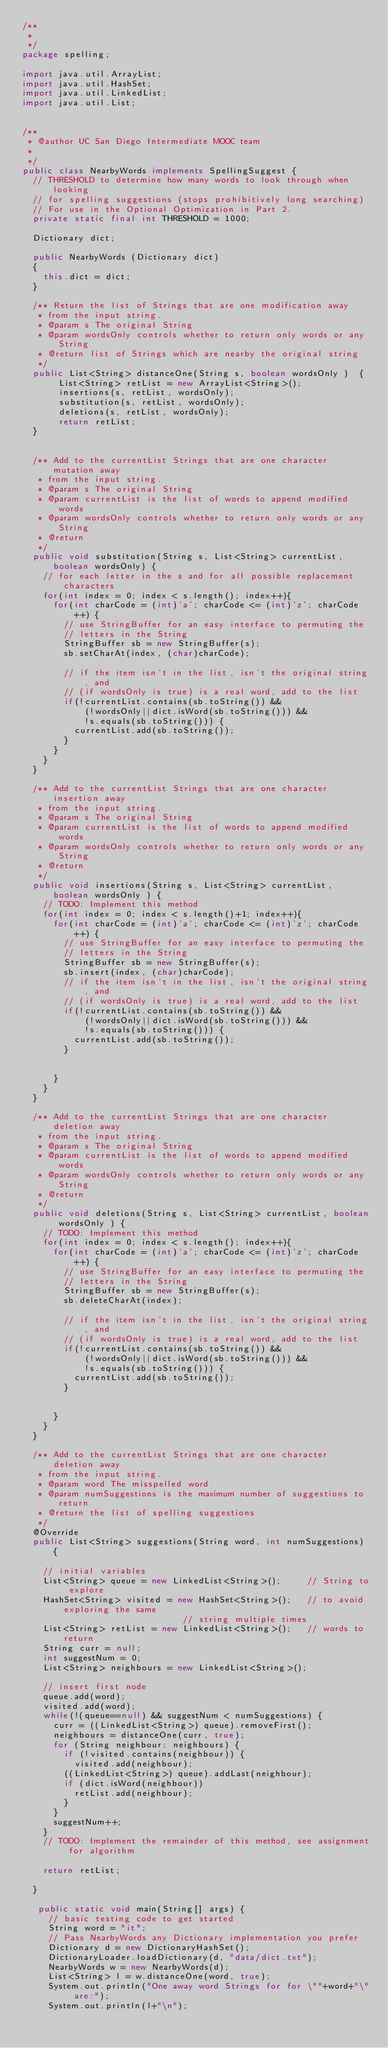<code> <loc_0><loc_0><loc_500><loc_500><_Java_>/**
 * 
 */
package spelling;

import java.util.ArrayList;
import java.util.HashSet;
import java.util.LinkedList;
import java.util.List;


/**
 * @author UC San Diego Intermediate MOOC team
 *
 */
public class NearbyWords implements SpellingSuggest {
	// THRESHOLD to determine how many words to look through when looking
	// for spelling suggestions (stops prohibitively long searching)
	// For use in the Optional Optimization in Part 2.
	private static final int THRESHOLD = 1000; 

	Dictionary dict;

	public NearbyWords (Dictionary dict) 
	{
		this.dict = dict;
	}

	/** Return the list of Strings that are one modification away
	 * from the input string.  
	 * @param s The original String
	 * @param wordsOnly controls whether to return only words or any String
	 * @return list of Strings which are nearby the original string
	 */
	public List<String> distanceOne(String s, boolean wordsOnly )  {
		   List<String> retList = new ArrayList<String>();
		   insertions(s, retList, wordsOnly);
		   substitution(s, retList, wordsOnly);
		   deletions(s, retList, wordsOnly);
		   return retList;
	}

	
	/** Add to the currentList Strings that are one character mutation away
	 * from the input string.  
	 * @param s The original String
	 * @param currentList is the list of words to append modified words 
	 * @param wordsOnly controls whether to return only words or any String
	 * @return
	 */
	public void substitution(String s, List<String> currentList, boolean wordsOnly) {
		// for each letter in the s and for all possible replacement characters
		for(int index = 0; index < s.length(); index++){
			for(int charCode = (int)'a'; charCode <= (int)'z'; charCode++) {
				// use StringBuffer for an easy interface to permuting the 
				// letters in the String
				StringBuffer sb = new StringBuffer(s);
				sb.setCharAt(index, (char)charCode);

				// if the item isn't in the list, isn't the original string, and
				// (if wordsOnly is true) is a real word, add to the list
				if(!currentList.contains(sb.toString()) && 
						(!wordsOnly||dict.isWord(sb.toString())) &&
						!s.equals(sb.toString())) {
					currentList.add(sb.toString());
				}
			}
		}
	}
	
	/** Add to the currentList Strings that are one character insertion away
	 * from the input string.  
	 * @param s The original String
	 * @param currentList is the list of words to append modified words 
	 * @param wordsOnly controls whether to return only words or any String
	 * @return
	 */
	public void insertions(String s, List<String> currentList, boolean wordsOnly ) {
		// TODO: Implement this method
		for(int index = 0; index < s.length()+1; index++){
			for(int charCode = (int)'a'; charCode <= (int)'z'; charCode++) {
				// use StringBuffer for an easy interface to permuting the 
				// letters in the String
				StringBuffer sb = new StringBuffer(s);
				sb.insert(index, (char)charCode);
				// if the item isn't in the list, isn't the original string, and
				// (if wordsOnly is true) is a real word, add to the list
				if(!currentList.contains(sb.toString()) && 
						(!wordsOnly||dict.isWord(sb.toString())) &&
						!s.equals(sb.toString())) {
					currentList.add(sb.toString());
				}
				
				
			}
		}
	}

	/** Add to the currentList Strings that are one character deletion away
	 * from the input string.  
	 * @param s The original String
	 * @param currentList is the list of words to append modified words 
	 * @param wordsOnly controls whether to return only words or any String
	 * @return
	 */
	public void deletions(String s, List<String> currentList, boolean wordsOnly ) {
		// TODO: Implement this method
		for(int index = 0; index < s.length(); index++){
			for(int charCode = (int)'a'; charCode <= (int)'z'; charCode++) {
				// use StringBuffer for an easy interface to permuting the 
				// letters in the String
				StringBuffer sb = new StringBuffer(s);
				sb.deleteCharAt(index);

				// if the item isn't in the list, isn't the original string, and
				// (if wordsOnly is true) is a real word, add to the list
				if(!currentList.contains(sb.toString()) && 
						(!wordsOnly||dict.isWord(sb.toString())) &&
						!s.equals(sb.toString())) {
					currentList.add(sb.toString());
				}
				
				
			}
		}
	}

	/** Add to the currentList Strings that are one character deletion away
	 * from the input string.  
	 * @param word The misspelled word
	 * @param numSuggestions is the maximum number of suggestions to return 
	 * @return the list of spelling suggestions
	 */
	@Override
	public List<String> suggestions(String word, int numSuggestions) {

		// initial variables
		List<String> queue = new LinkedList<String>();     // String to explore
		HashSet<String> visited = new HashSet<String>();   // to avoid exploring the same  
														   // string multiple times
		List<String> retList = new LinkedList<String>();   // words to return
		String curr = null;
		int suggestNum = 0;
		List<String> neighbours = new LinkedList<String>();
		
		// insert first node
		queue.add(word);
		visited.add(word);
		while(!(queue==null) && suggestNum < numSuggestions) {
			curr = ((LinkedList<String>) queue).removeFirst();
			neighbours = distanceOne(curr, true);
			for (String neighbour: neighbours) {
				if (!visited.contains(neighbour)) {
					visited.add(neighbour);
				((LinkedList<String>) queue).addLast(neighbour);
				if (dict.isWord(neighbour))
					retList.add(neighbour);
				}
			}
			suggestNum++;
		}
		// TODO: Implement the remainder of this method, see assignment for algorithm
		
		return retList;

	}	

   public static void main(String[] args) {
	   // basic testing code to get started
	   String word = "it";
	   // Pass NearbyWords any Dictionary implementation you prefer
	   Dictionary d = new DictionaryHashSet();
	   DictionaryLoader.loadDictionary(d, "data/dict.txt");
	   NearbyWords w = new NearbyWords(d);
	   List<String> l = w.distanceOne(word, true);
	   System.out.println("One away word Strings for for \""+word+"\" are:");
	   System.out.println(l+"\n");
</code> 